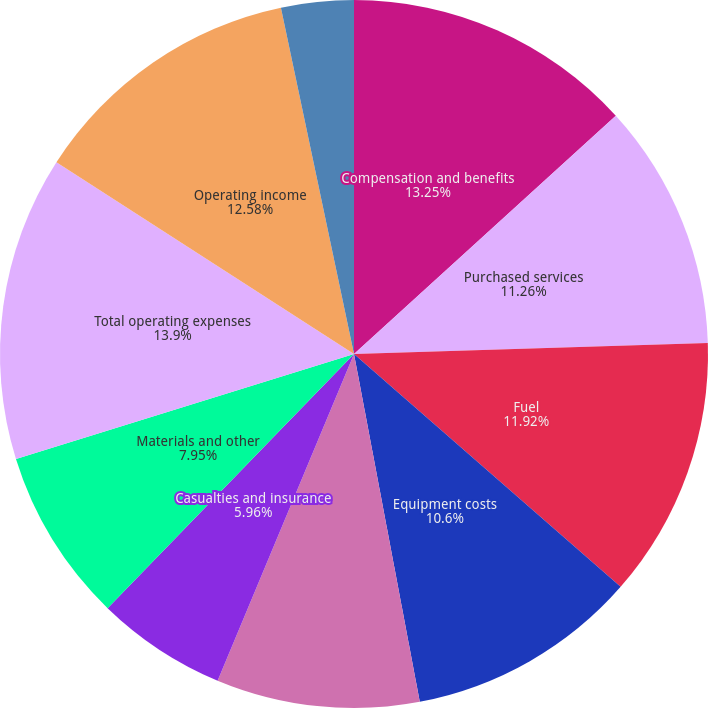Convert chart. <chart><loc_0><loc_0><loc_500><loc_500><pie_chart><fcel>Compensation and benefits<fcel>Purchased services<fcel>Fuel<fcel>Equipment costs<fcel>Depreciation and amortization<fcel>Casualties and insurance<fcel>Materials and other<fcel>Total operating expenses<fcel>Operating income<fcel>Equity in net earnings of<nl><fcel>13.25%<fcel>11.26%<fcel>11.92%<fcel>10.6%<fcel>9.27%<fcel>5.96%<fcel>7.95%<fcel>13.91%<fcel>12.58%<fcel>3.31%<nl></chart> 